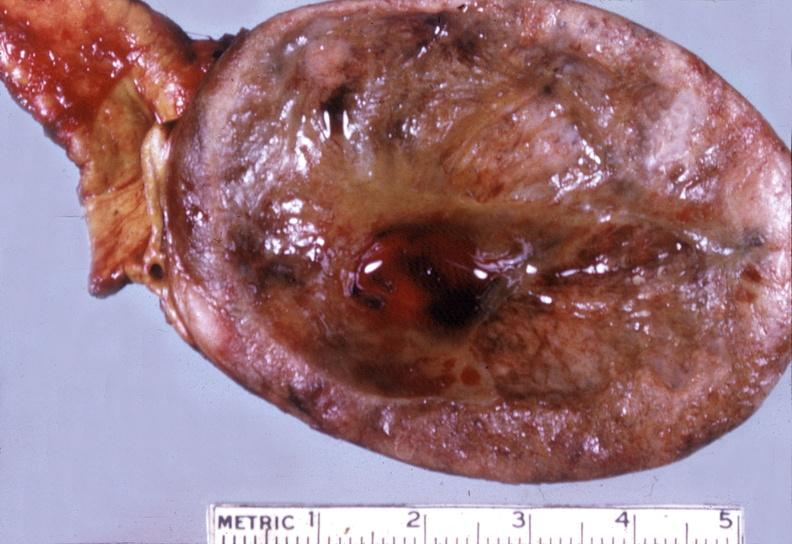where does this belong to?
Answer the question using a single word or phrase. Endocrine system 